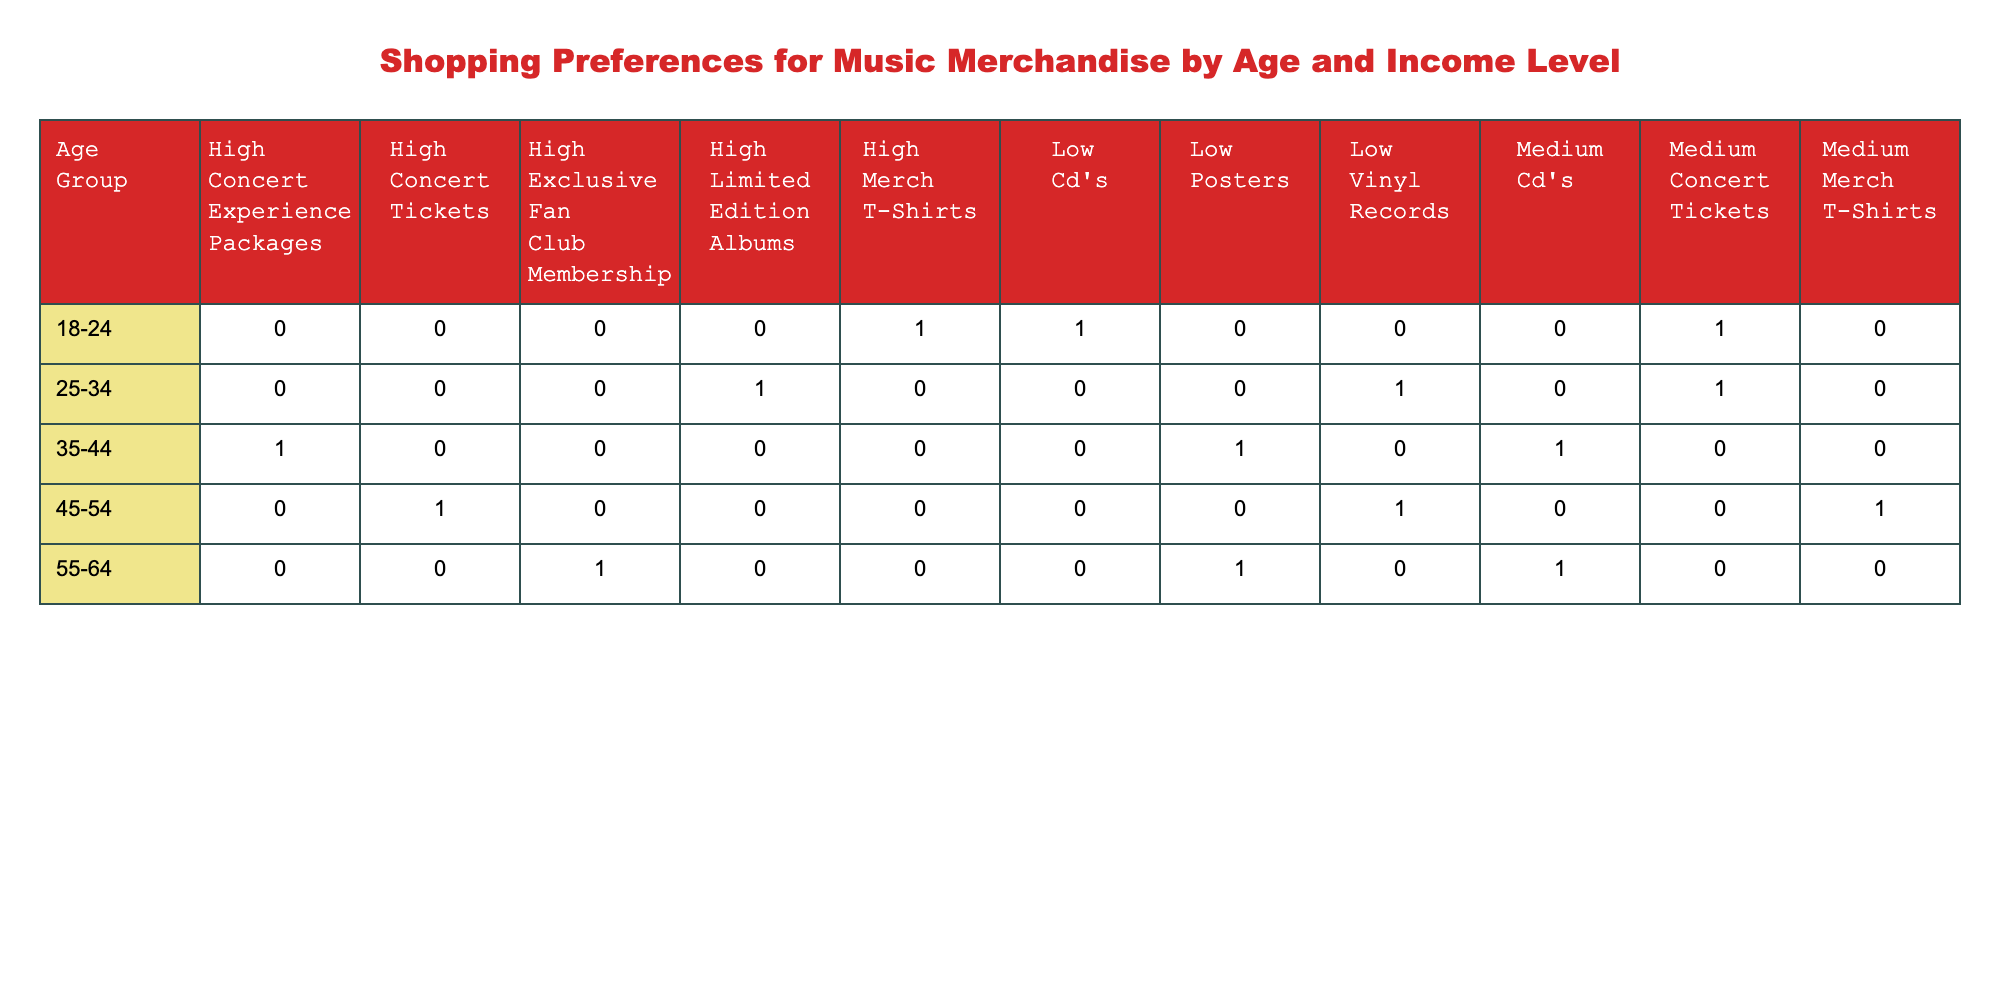What type of merchandise is most preferred by the 25-34 age group? Looking at the table, the highest purchase frequency for the 25-34 age group is 5 for Concert Tickets.
Answer: Concert Tickets How many types of merchandise do individuals aged 55-64 prefer? The table shows three different types of merchandise preferred by the 55-64 age group: Posters, Cd's, and Exclusive Fan Club Membership.
Answer: 3 What is the sum of purchase frequencies for all merchandise types in the 35-44 age group? The purchase frequencies for the 35-44 age group are 4 (Posters) + 5 (Cd's) + 2 (Concert Experience Packages) = 11.
Answer: 11 Do individuals aged 45-54 prefer more merchandise types at medium income level compared to low income level? At medium income level, the 45-54 age group prefers 1 type (Merch T-Shirts), while at low income level they prefer 1 type (Vinyl Records); so they do not prefer more.
Answer: No Which income level shows the highest purchase frequency for merchandise in the 18-24 age group? In the 18-24 age group, the highest purchase frequency is 4, which corresponds to the High income level for Merch T-Shirts.
Answer: High income level What is the average purchase frequency for low-income individuals across all age groups? Summing up the purchase frequencies for low-income individuals: 2 (Cd's, 18-24) + 1 (Vinyl Records, 25-34) + 4 (Posters, 35-44) + 2 (Vinyl Records, 45-54) + 1 (Posters, 55-64) = 10. There are 5 data points, so average = 10 / 5 = 2.
Answer: 2 Are there any individuals aged 55-64 who prefer Merch T-Shirts? The table shows no entries for Merch T-Shirts in the 55-64 age group, indicating they do not prefer it.
Answer: No Which preferred merchandise type has the lowest overall purchase frequency across all groups? By examining the table, the lowest purchase frequency is 1 for both Vinyl Records (25-34 age group, Low income) and Exclusive Fan Club Membership (55-64 age group, High income). They have the same lowest frequency.
Answer: Vinyl Records and Exclusive Fan Club Membership 